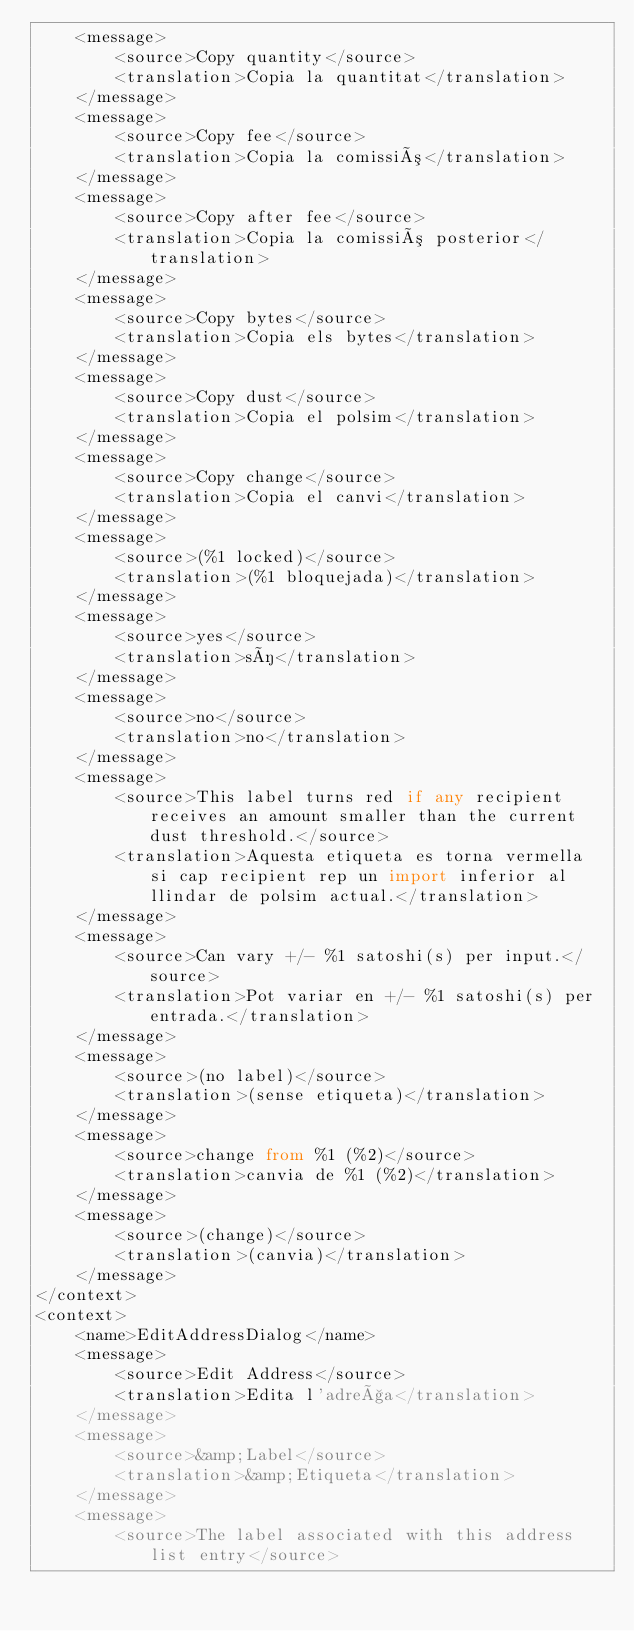<code> <loc_0><loc_0><loc_500><loc_500><_TypeScript_>    <message>
        <source>Copy quantity</source>
        <translation>Copia la quantitat</translation>
    </message>
    <message>
        <source>Copy fee</source>
        <translation>Copia la comissió</translation>
    </message>
    <message>
        <source>Copy after fee</source>
        <translation>Copia la comissió posterior</translation>
    </message>
    <message>
        <source>Copy bytes</source>
        <translation>Copia els bytes</translation>
    </message>
    <message>
        <source>Copy dust</source>
        <translation>Copia el polsim</translation>
    </message>
    <message>
        <source>Copy change</source>
        <translation>Copia el canvi</translation>
    </message>
    <message>
        <source>(%1 locked)</source>
        <translation>(%1 bloquejada)</translation>
    </message>
    <message>
        <source>yes</source>
        <translation>sí</translation>
    </message>
    <message>
        <source>no</source>
        <translation>no</translation>
    </message>
    <message>
        <source>This label turns red if any recipient receives an amount smaller than the current dust threshold.</source>
        <translation>Aquesta etiqueta es torna vermella si cap recipient rep un import inferior al llindar de polsim actual.</translation>
    </message>
    <message>
        <source>Can vary +/- %1 satoshi(s) per input.</source>
        <translation>Pot variar en +/- %1 satoshi(s) per entrada.</translation>
    </message>
    <message>
        <source>(no label)</source>
        <translation>(sense etiqueta)</translation>
    </message>
    <message>
        <source>change from %1 (%2)</source>
        <translation>canvia de %1 (%2)</translation>
    </message>
    <message>
        <source>(change)</source>
        <translation>(canvia)</translation>
    </message>
</context>
<context>
    <name>EditAddressDialog</name>
    <message>
        <source>Edit Address</source>
        <translation>Edita l'adreça</translation>
    </message>
    <message>
        <source>&amp;Label</source>
        <translation>&amp;Etiqueta</translation>
    </message>
    <message>
        <source>The label associated with this address list entry</source></code> 